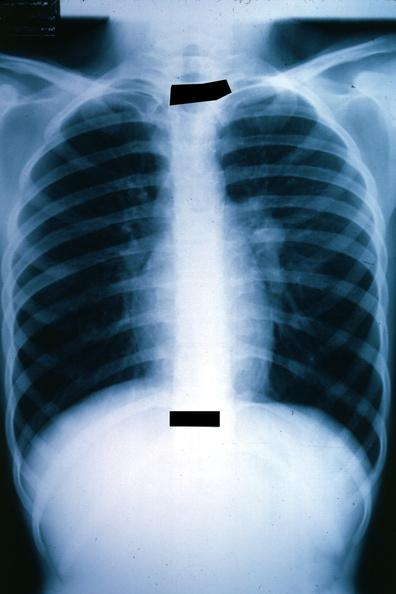s metastatic malignant ependymoma present?
Answer the question using a single word or phrase. Yes 